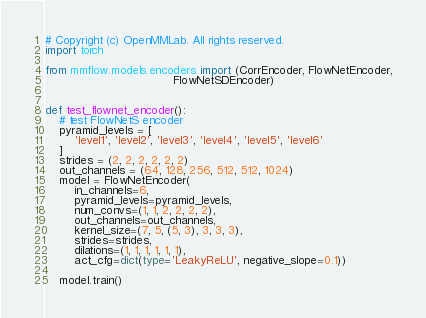<code> <loc_0><loc_0><loc_500><loc_500><_Python_># Copyright (c) OpenMMLab. All rights reserved.
import torch

from mmflow.models.encoders import (CorrEncoder, FlowNetEncoder,
                                    FlowNetSDEncoder)


def test_flownet_encoder():
    # test FlowNetS encoder
    pyramid_levels = [
        'level1', 'level2', 'level3', 'level4', 'level5', 'level6'
    ]
    strides = (2, 2, 2, 2, 2, 2)
    out_channels = (64, 128, 256, 512, 512, 1024)
    model = FlowNetEncoder(
        in_channels=6,
        pyramid_levels=pyramid_levels,
        num_convs=(1, 1, 2, 2, 2, 2),
        out_channels=out_channels,
        kernel_size=(7, 5, (5, 3), 3, 3, 3),
        strides=strides,
        dilations=(1, 1, 1, 1, 1, 1),
        act_cfg=dict(type='LeakyReLU', negative_slope=0.1))

    model.train()
</code> 